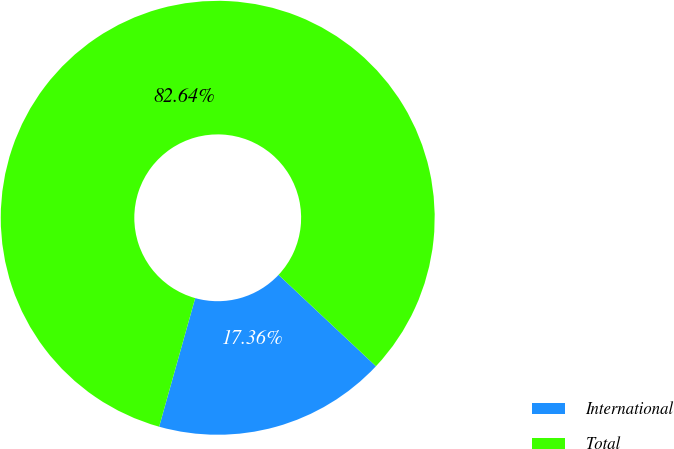<chart> <loc_0><loc_0><loc_500><loc_500><pie_chart><fcel>International<fcel>Total<nl><fcel>17.36%<fcel>82.64%<nl></chart> 